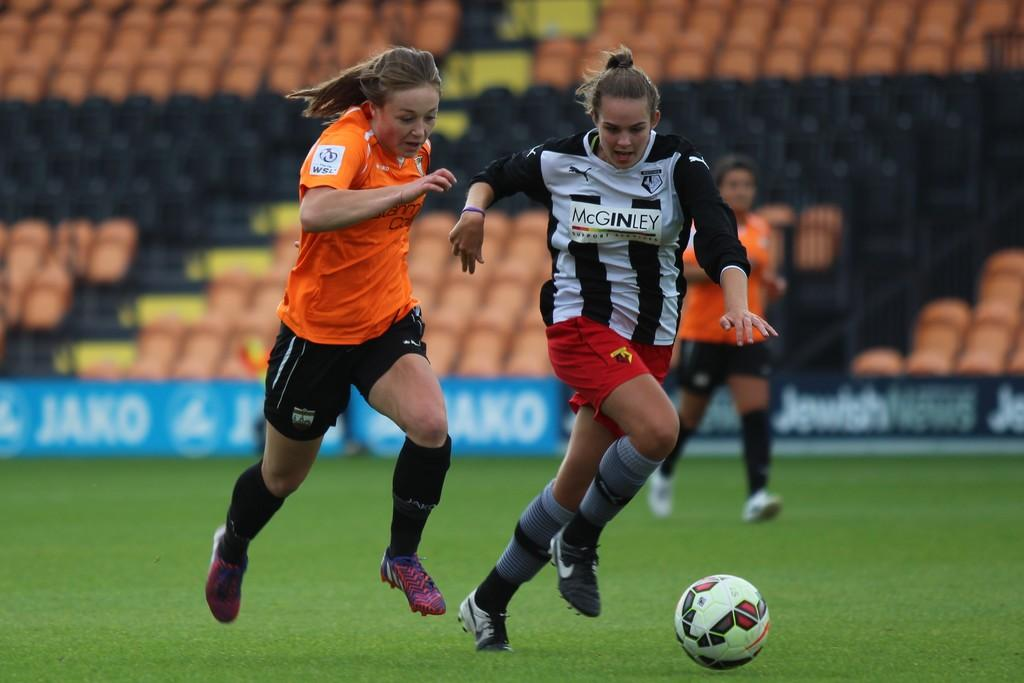Provide a one-sentence caption for the provided image. Three female soccer players dressed in McGinley and WSL uniforms and cleats chasing after a soccer ball. 